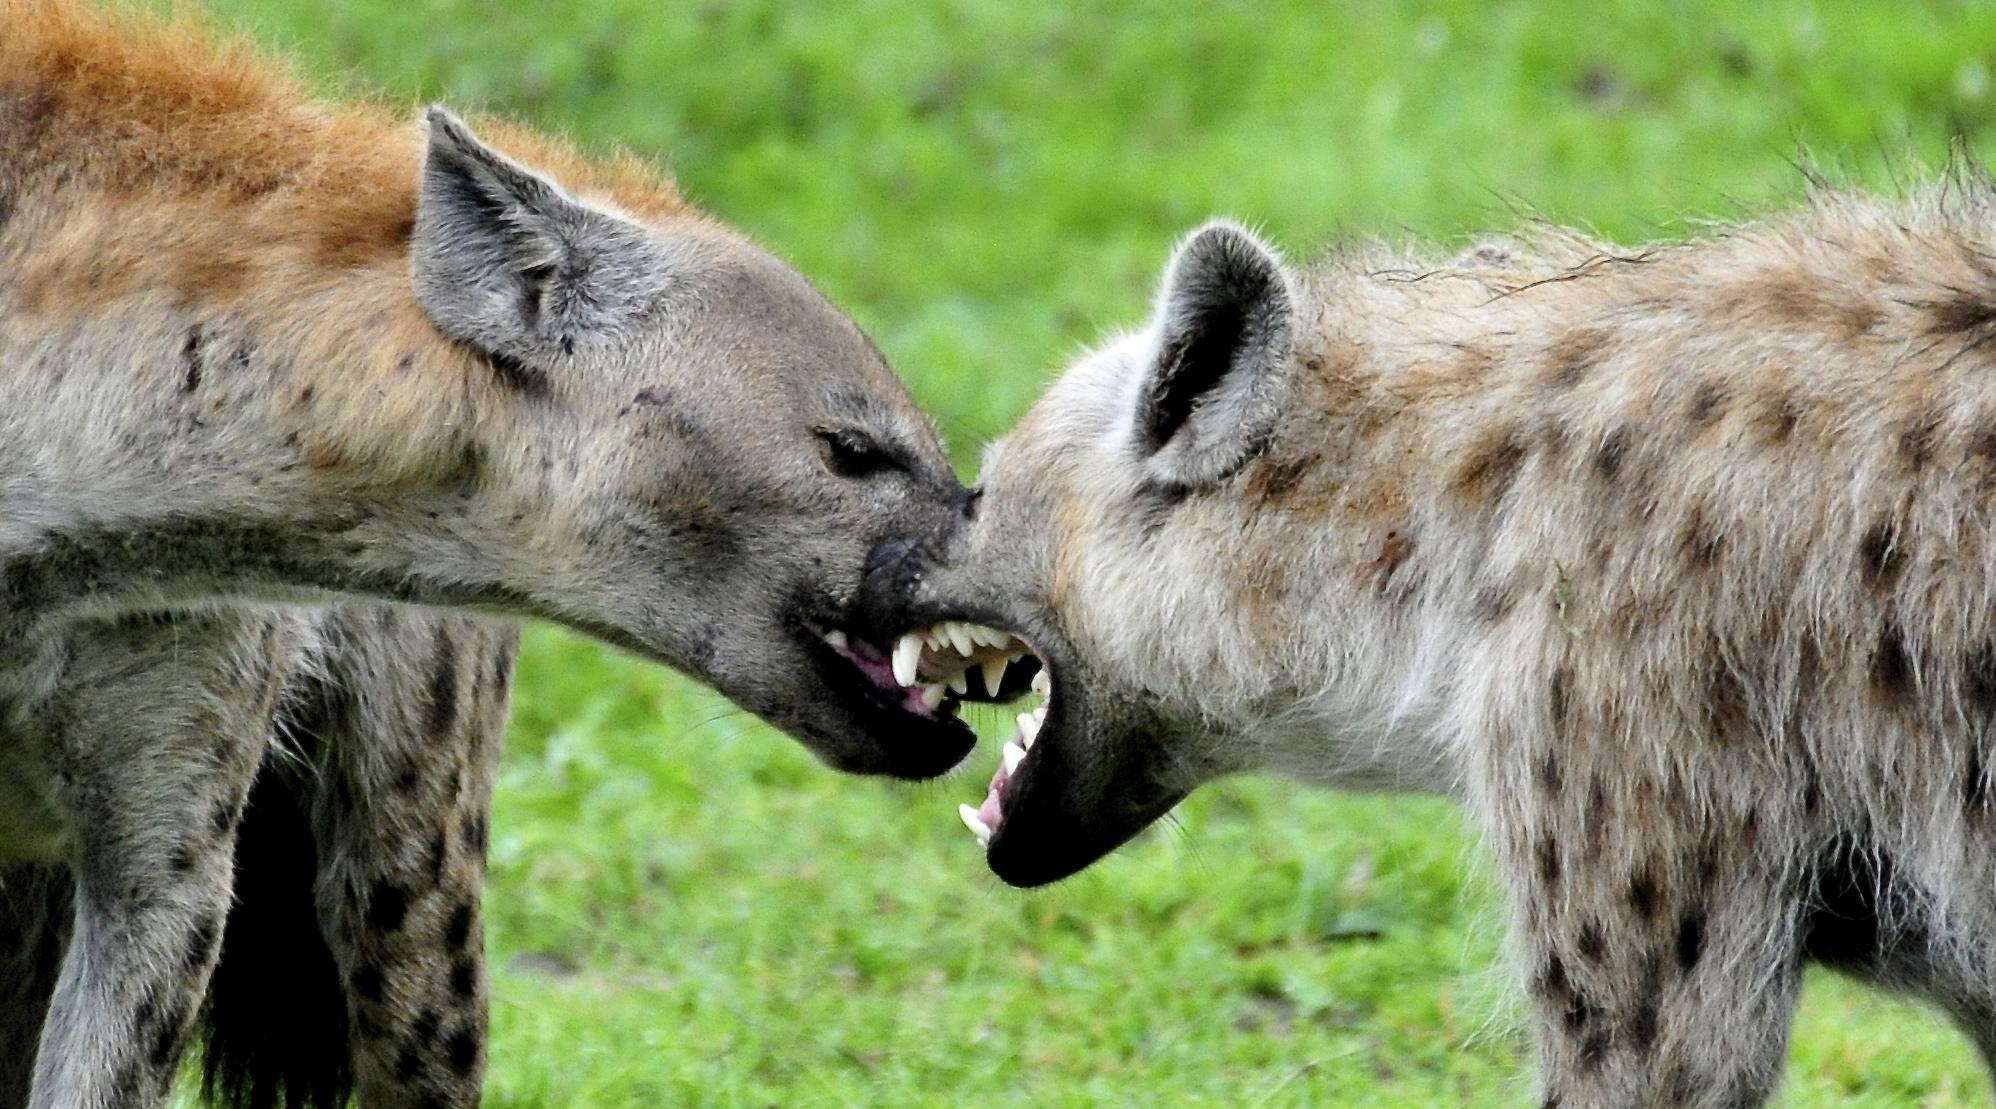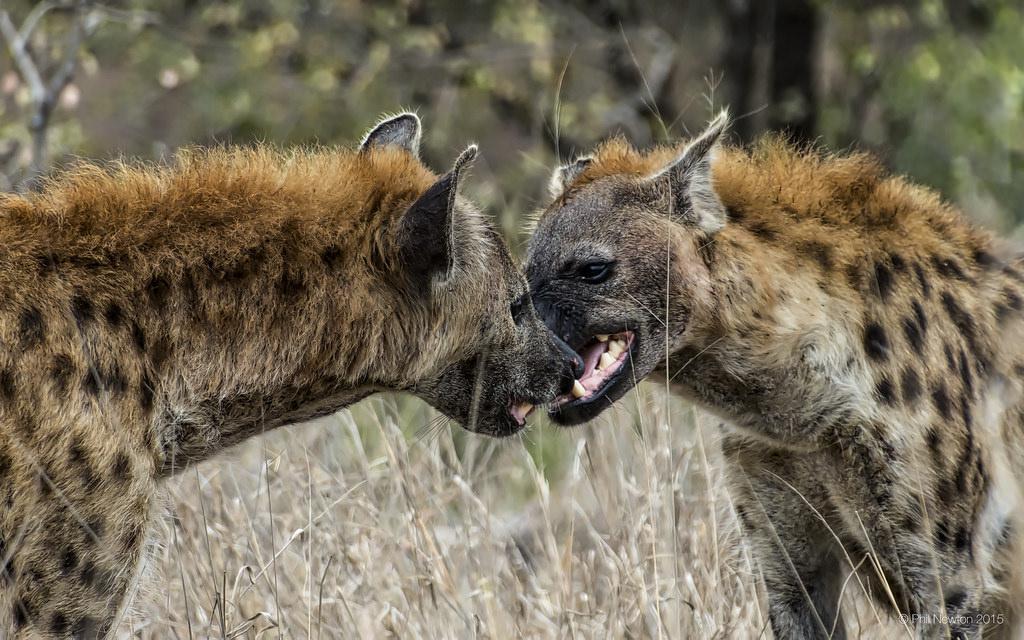The first image is the image on the left, the second image is the image on the right. Analyze the images presented: Is the assertion "There are at least three hyenas eating  a dead animal." valid? Answer yes or no. No. 